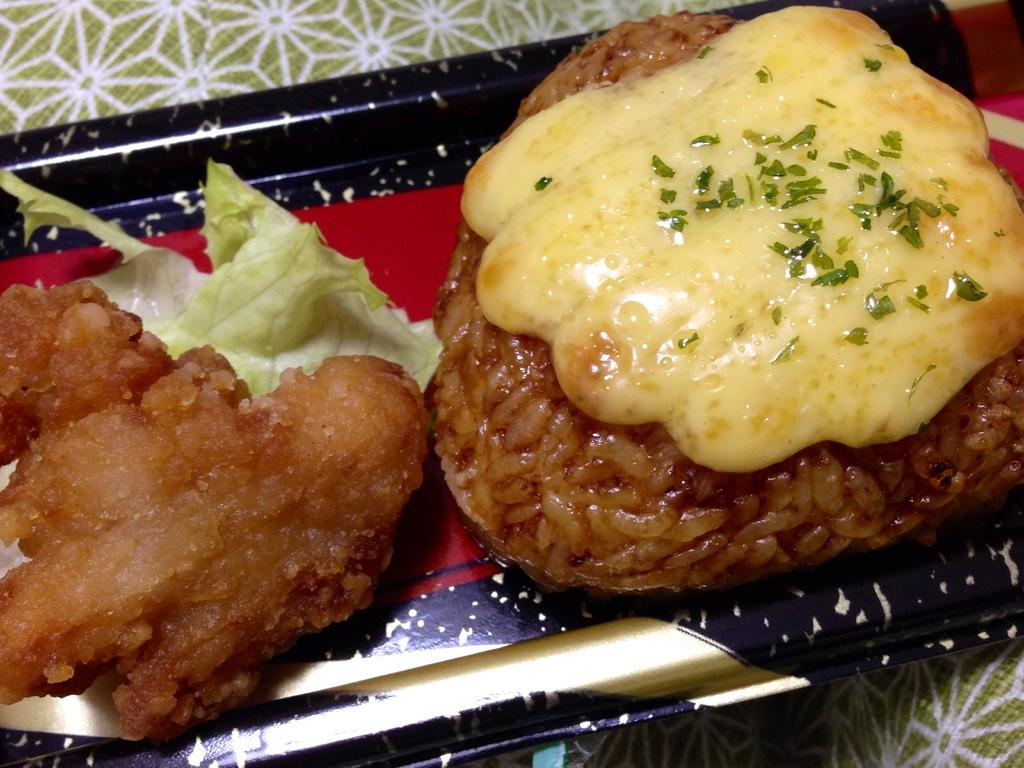What is the main subject of the image? The main subject of the image is a plate with food items in the center. Can you describe the food items in the plate? Unfortunately, the facts provided do not give any details about the food items in the plate. What is at the bottom of the image? There is cloth at the bottom of the image. How does the beggar interact with the cook during the rainstorm in the image? There is no beggar, cook, or rainstorm present in the image. The image only features a plate with food items and cloth at the bottom. 